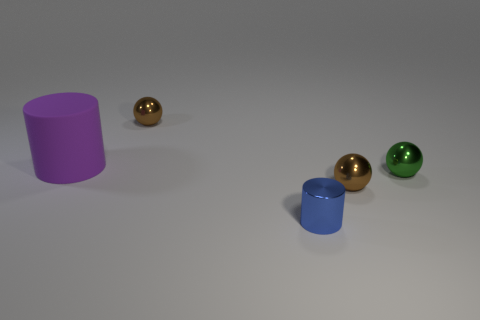Add 4 big purple objects. How many objects exist? 9 Subtract all cylinders. How many objects are left? 3 Subtract 0 gray balls. How many objects are left? 5 Subtract all small green metallic objects. Subtract all yellow things. How many objects are left? 4 Add 4 tiny cylinders. How many tiny cylinders are left? 5 Add 2 shiny spheres. How many shiny spheres exist? 5 